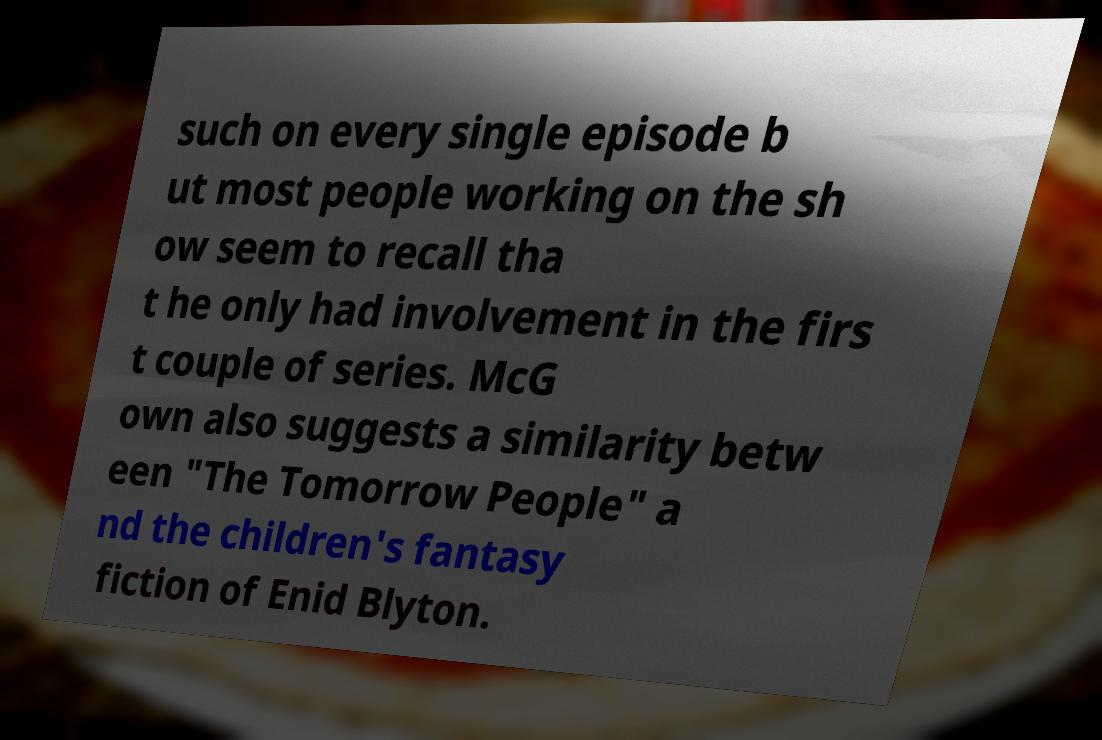There's text embedded in this image that I need extracted. Can you transcribe it verbatim? such on every single episode b ut most people working on the sh ow seem to recall tha t he only had involvement in the firs t couple of series. McG own also suggests a similarity betw een "The Tomorrow People" a nd the children's fantasy fiction of Enid Blyton. 